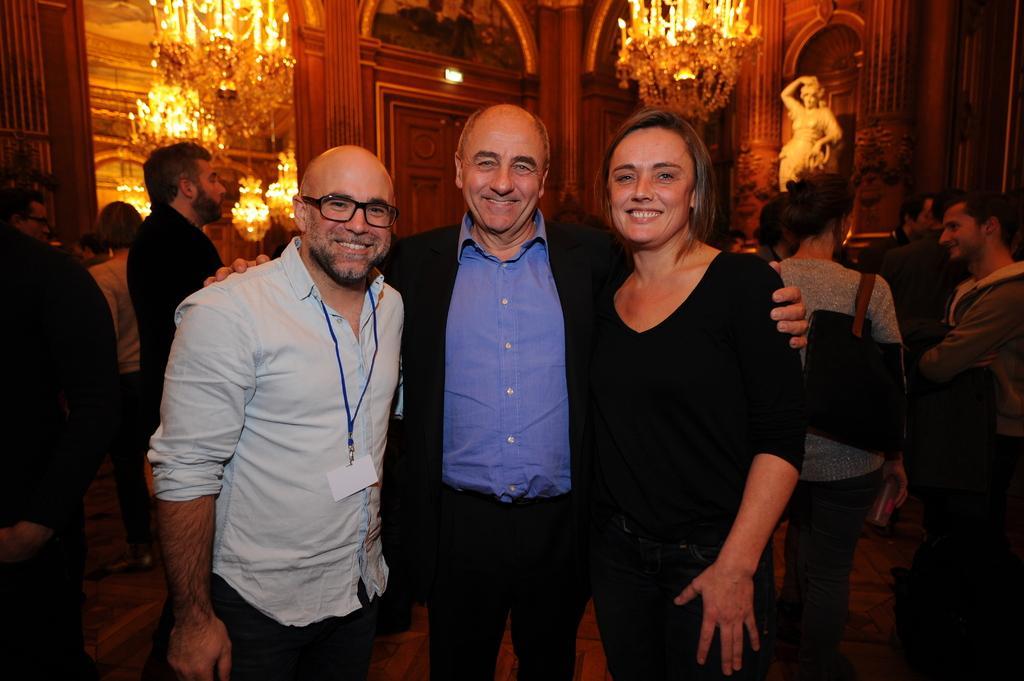In one or two sentences, can you explain what this image depicts? In this image I can see three persons standing, the person at right is wearing black color dress and the person at left is wearing white shirt, black pant. Background I can see few other persons standing, few statues and few chandeliers. 